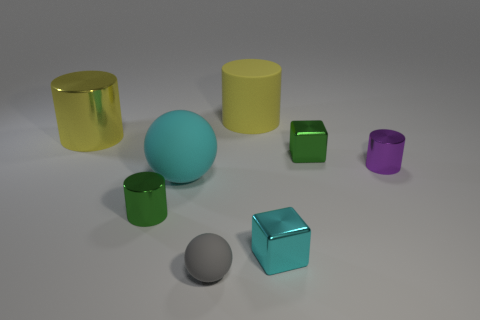What number of things are either cylinders that are in front of the cyan matte ball or big yellow things on the left side of the tiny gray ball? There are two objects that meet the criteria: one cylinder in front of the cyan matte ball and one large yellow object to the left of the tiny gray ball. 